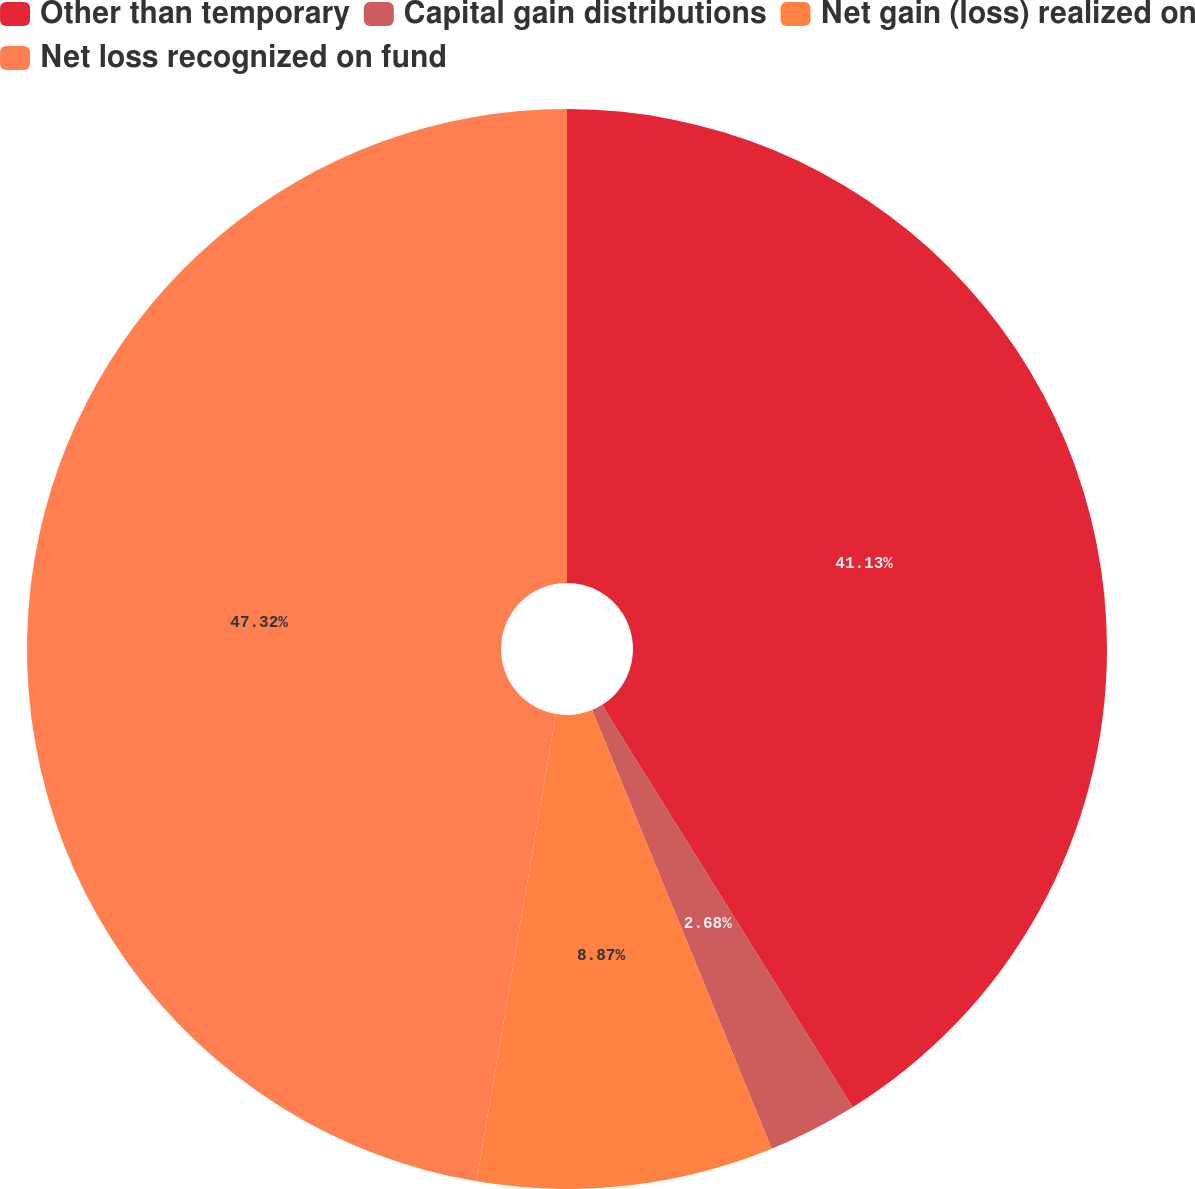Convert chart to OTSL. <chart><loc_0><loc_0><loc_500><loc_500><pie_chart><fcel>Other than temporary<fcel>Capital gain distributions<fcel>Net gain (loss) realized on<fcel>Net loss recognized on fund<nl><fcel>41.13%<fcel>2.68%<fcel>8.87%<fcel>47.32%<nl></chart> 